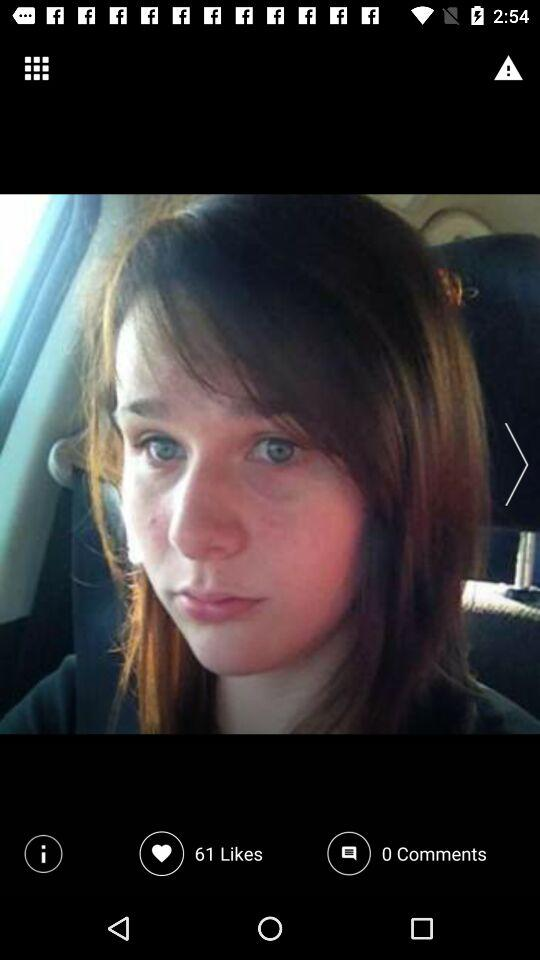How many likes are there? There are 61 likes. 